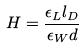<formula> <loc_0><loc_0><loc_500><loc_500>H = \frac { \epsilon _ { L } l _ { D } } { \epsilon _ { W } d }</formula> 